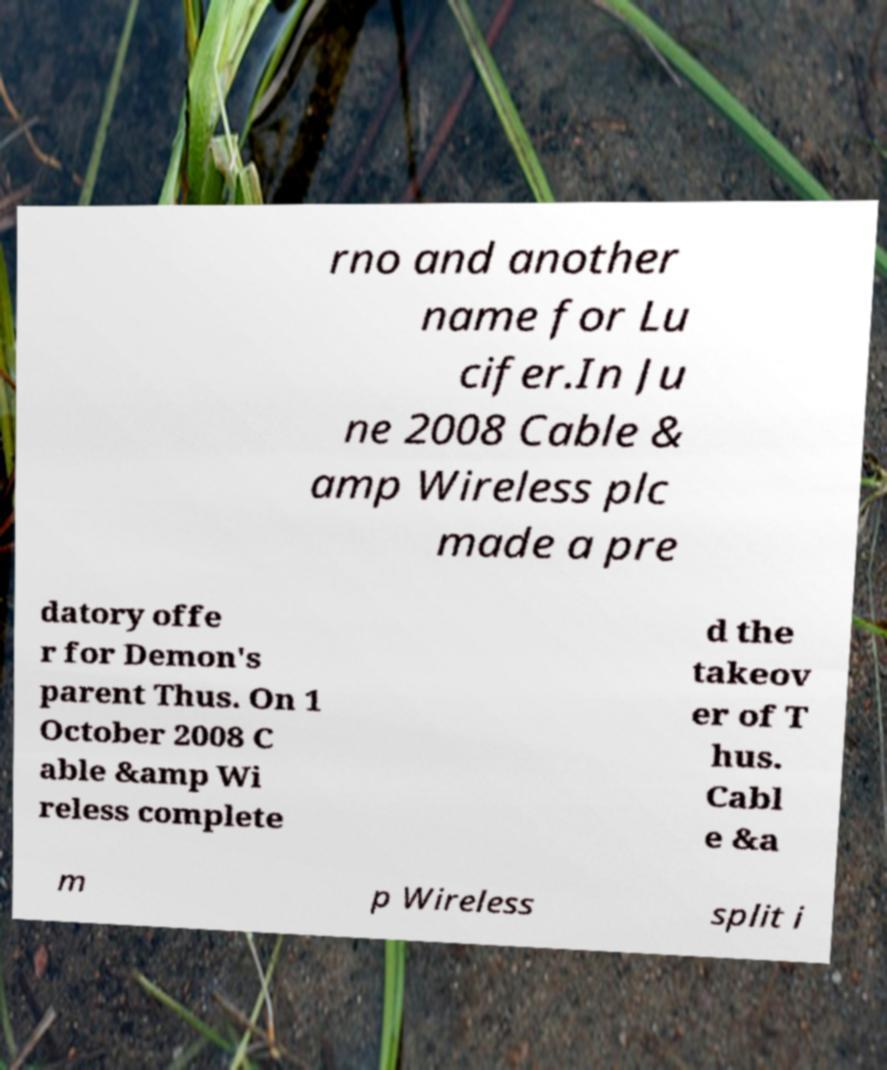What messages or text are displayed in this image? I need them in a readable, typed format. rno and another name for Lu cifer.In Ju ne 2008 Cable & amp Wireless plc made a pre datory offe r for Demon's parent Thus. On 1 October 2008 C able &amp Wi reless complete d the takeov er of T hus. Cabl e &a m p Wireless split i 